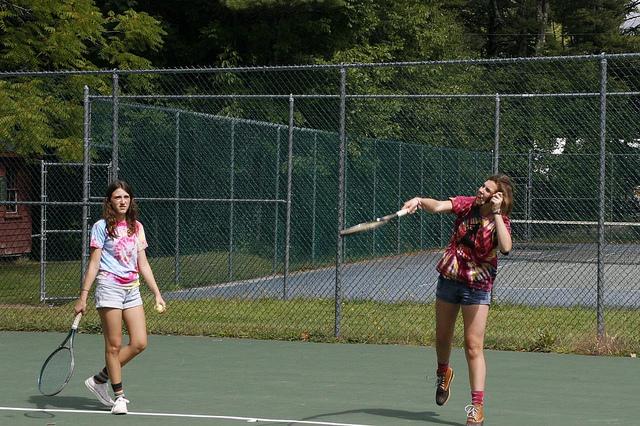Are they on a tennis court?
Write a very short answer. Yes. What color are her shoes?
Keep it brief. White. What sport are the people playing?
Quick response, please. Tennis. Is she talking on the phone?
Quick response, please. Yes. Does the scene take place in winter?
Write a very short answer. No. 